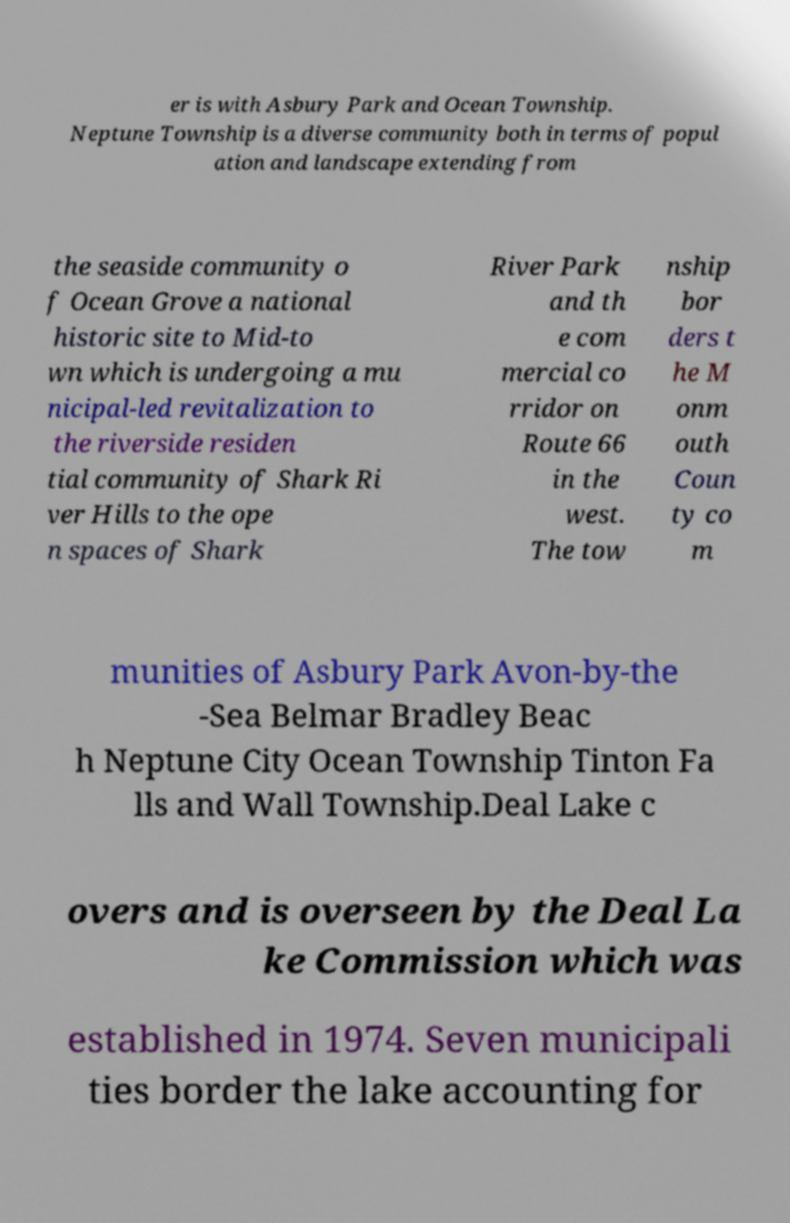Can you read and provide the text displayed in the image?This photo seems to have some interesting text. Can you extract and type it out for me? er is with Asbury Park and Ocean Township. Neptune Township is a diverse community both in terms of popul ation and landscape extending from the seaside community o f Ocean Grove a national historic site to Mid-to wn which is undergoing a mu nicipal-led revitalization to the riverside residen tial community of Shark Ri ver Hills to the ope n spaces of Shark River Park and th e com mercial co rridor on Route 66 in the west. The tow nship bor ders t he M onm outh Coun ty co m munities of Asbury Park Avon-by-the -Sea Belmar Bradley Beac h Neptune City Ocean Township Tinton Fa lls and Wall Township.Deal Lake c overs and is overseen by the Deal La ke Commission which was established in 1974. Seven municipali ties border the lake accounting for 